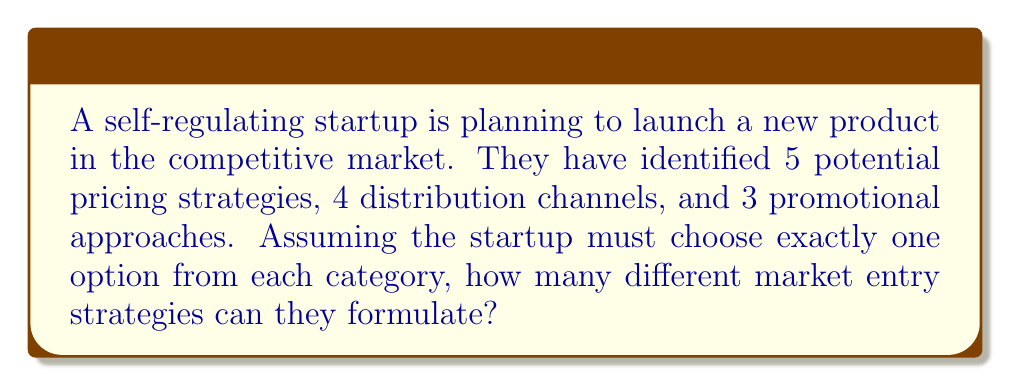Help me with this question. To solve this problem, we'll use the multiplication principle of combinatorics. This principle states that if we have a sequence of independent choices, the total number of ways to make these choices is the product of the number of ways to make each individual choice.

Let's break down the problem:

1. Pricing strategies: 5 options
2. Distribution channels: 4 options
3. Promotional approaches: 3 options

For each market entry strategy, the startup must choose:
- 1 pricing strategy out of 5
- 1 distribution channel out of 4
- 1 promotional approach out of 3

Since these choices are independent (the choice of one doesn't affect the others), we multiply the number of options for each:

$$ \text{Total number of strategies} = 5 \times 4 \times 3 $$

Calculating this:

$$ 5 \times 4 \times 3 = 60 $$

Therefore, the startup can formulate 60 different market entry strategies.

This approach allows for maximum flexibility in the free market, enabling the startup to test various combinations and let market forces determine the most effective strategy.
Answer: 60 